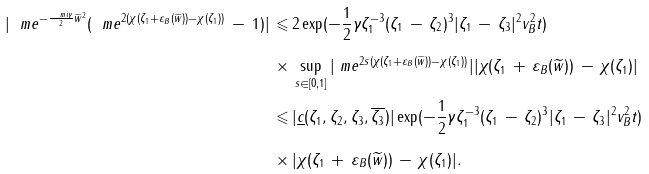Convert formula to latex. <formula><loc_0><loc_0><loc_500><loc_500>| \ m e ^ { - \frac { \ m i \gamma } { 2 } \widetilde { w } ^ { 2 } } ( \ m e ^ { 2 ( \chi ( \zeta _ { 1 } + \varepsilon _ { B } ( \widetilde { w } ) ) - \chi ( \zeta _ { 1 } ) ) } \, - \, 1 ) | \, \leqslant & \, 2 \exp ( - \frac { 1 } { 2 } \gamma \zeta _ { 1 } ^ { - 3 } ( \zeta _ { 1 } \, - \, \zeta _ { 2 } ) ^ { 3 } | \zeta _ { 1 } \, - \, \zeta _ { 3 } | ^ { 2 } v _ { B } ^ { 2 } t ) \\ \times & \, \sup _ { s \in [ 0 , 1 ] } | \ m e ^ { 2 s ( \chi ( \zeta _ { 1 } + \varepsilon _ { B } ( \widetilde { w } ) ) - \chi ( \zeta _ { 1 } ) ) } | | \chi ( \zeta _ { 1 } \, + \, \varepsilon _ { B } ( \widetilde { w } ) ) \, - \, \chi ( \zeta _ { 1 } ) | \\ \leqslant & \, | \underline { c } ( \zeta _ { 1 } , \zeta _ { 2 } , \zeta _ { 3 } , \overline { \zeta _ { 3 } } ) | \exp ( - \frac { 1 } { 2 } \gamma \zeta _ { 1 } ^ { - 3 } ( \zeta _ { 1 } \, - \, \zeta _ { 2 } ) ^ { 3 } | \zeta _ { 1 } \, - \, \zeta _ { 3 } | ^ { 2 } v _ { B } ^ { 2 } t ) \\ \times & \, | \chi ( \zeta _ { 1 } \, + \, \varepsilon _ { B } ( \widetilde { w } ) ) \, - \, \chi ( \zeta _ { 1 } ) | .</formula> 